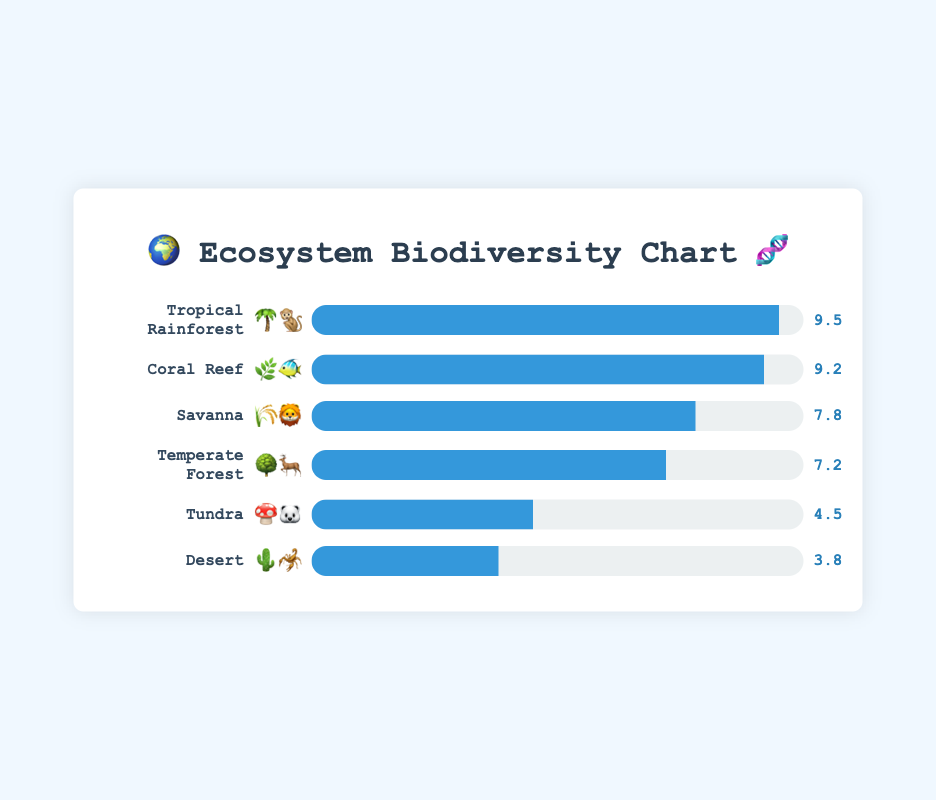What's the title of the figure? The title is prominently placed at the top of the chart and reads "🌍 Ecosystem Biodiversity Chart 🧬".
Answer: 🌍 Ecosystem Biodiversity Chart 🧬 Which ecosystem has the highest biodiversity index? The ecosystem with the highest biodiversity index is indicated by the longest progress bar in the chart. This belongs to the Tropical Rainforest, with a biodiversity index of 9.5.
Answer: Tropical Rainforest What's the difference in biodiversity index between the Coral Reef and Desert ecosystems? The biodiversity index for the Coral Reef is 9.2, and for the Desert, it is 3.8. The difference is calculated as 9.2 - 3.8.
Answer: 5.4 Which two ecosystems have the closest biodiversity indexes? By examining the lengths of the progress bars and the numerical values provided, the Temperate Forest (7.2) and the Savanna (7.8) have the closest biodiversity indexes.
Answer: Temperate Forest and Savanna Out of the six ecosystems, how many have a biodiversity index greater than 7? By checking the biodiversity indexes, we see that the Tropical Rainforest (9.5), Coral Reef (9.2), Savanna (7.8), and Temperate Forest (7.2) all have values greater than 7. Counting these gives us four ecosystems.
Answer: Four What's the average biodiversity index of all the ecosystems? The biodiversity indexes are 9.5, 9.2, 7.8, 7.2, 4.5, and 3.8. Adding these gives a total of 42. Subtracting it by the number of ecosystems (6), we find the average: 42 / 6 = 7.
Answer: 7 If the biodiversity index represents the percentage of species diversity, which ecosystem has less than half the maximum diversity value? Half of the maximum biodiversity index (9.5) would be 4.75. Ecosystems with indexes less than 4.75 are Tundra (4.5) and Desert (3.8).
Answer: Tundra and Desert What plant and animal emoji representation is used for the Savanna ecosystem? The plant and animal emojis for the Savanna ecosystem are displayed next to its name in the figure, which are 🌾 and 🦁 respectively.
Answer: 🌾🦁 Arrange the ecosystems in descending order of their biodiversity index. By looking at the biodiversity indexes and sorting them from highest to lowest, we get: Tropical Rainforest (9.5), Coral Reef (9.2), Savanna (7.8), Temperate Forest (7.2), Tundra (4.5), and Desert (3.8).
Answer: Tropical Rainforest, Coral Reef, Savanna, Temperate Forest, Tundra, Desert 